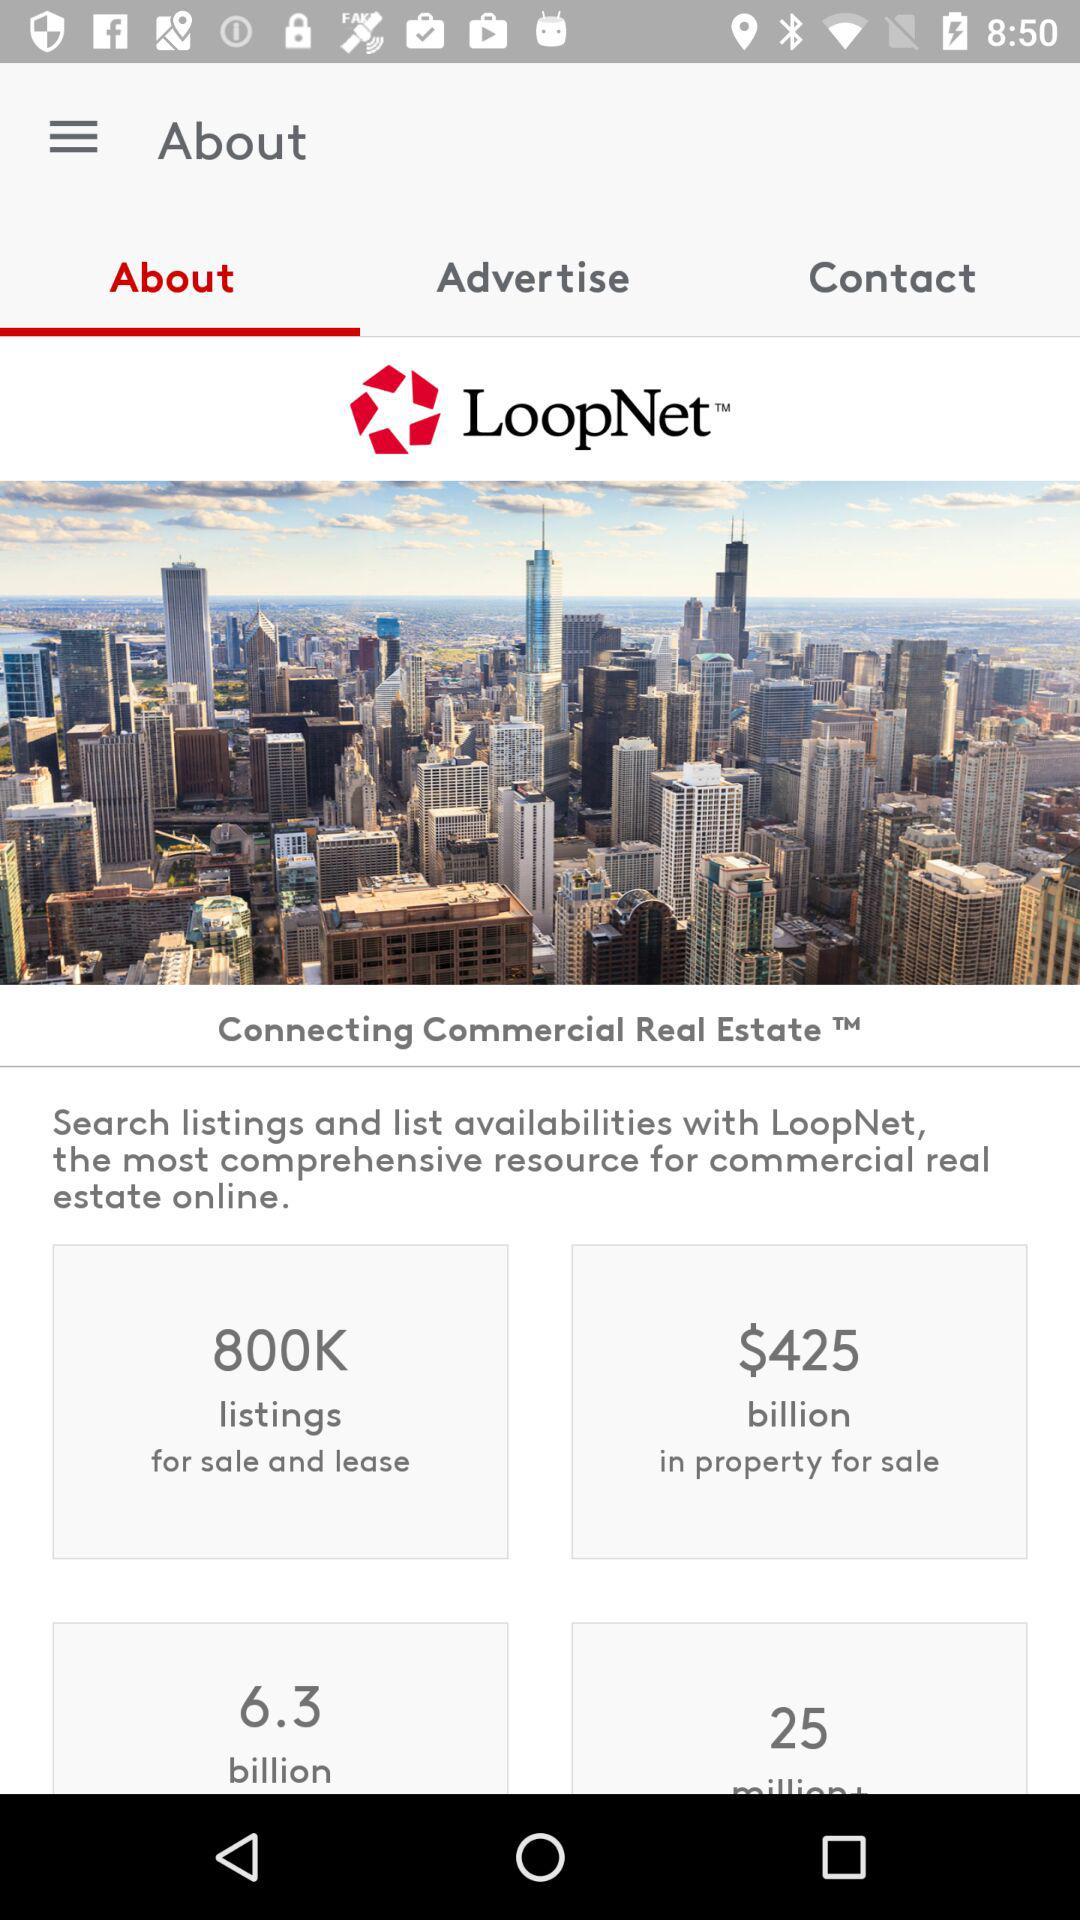Which tab is selected? The selected tab is "About". 